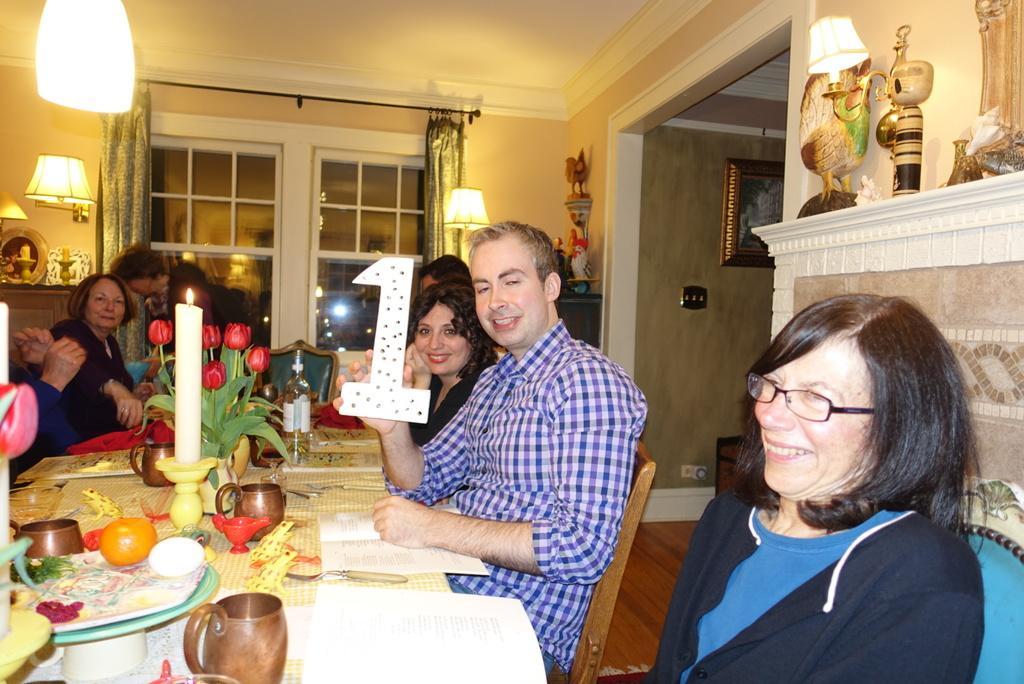Please provide a concise description of this image. In this image I can see the group of people sitting on the chairs. Among them one person is wearing the jacket and another one is holding the number one. They are sitting in front of the table. On the table there are glasses,papers,candle,flower vase. In the back there is a lamp and a curtains to the window. To the right there are toys on the table. And frames to the wall. 